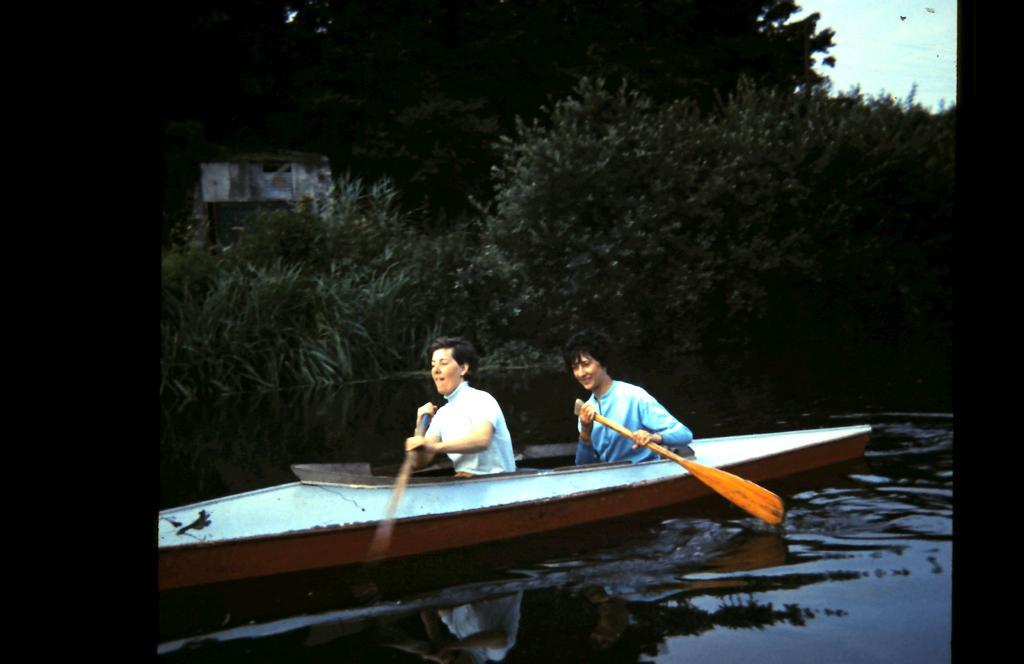What are the people in the image doing? The people in the image are riding a boat. What is the primary setting for the activity in the image? There is water visible in the image. What type of vegetation can be seen in the image? There are trees in the image. How would you describe the weather based on the sky in the image? The sky is blue and cloudy in the image. What type of honey can be seen dripping from the trees in the image? There is no honey present in the image; it features people riding a boat in a water setting with trees and a blue, cloudy sky. 